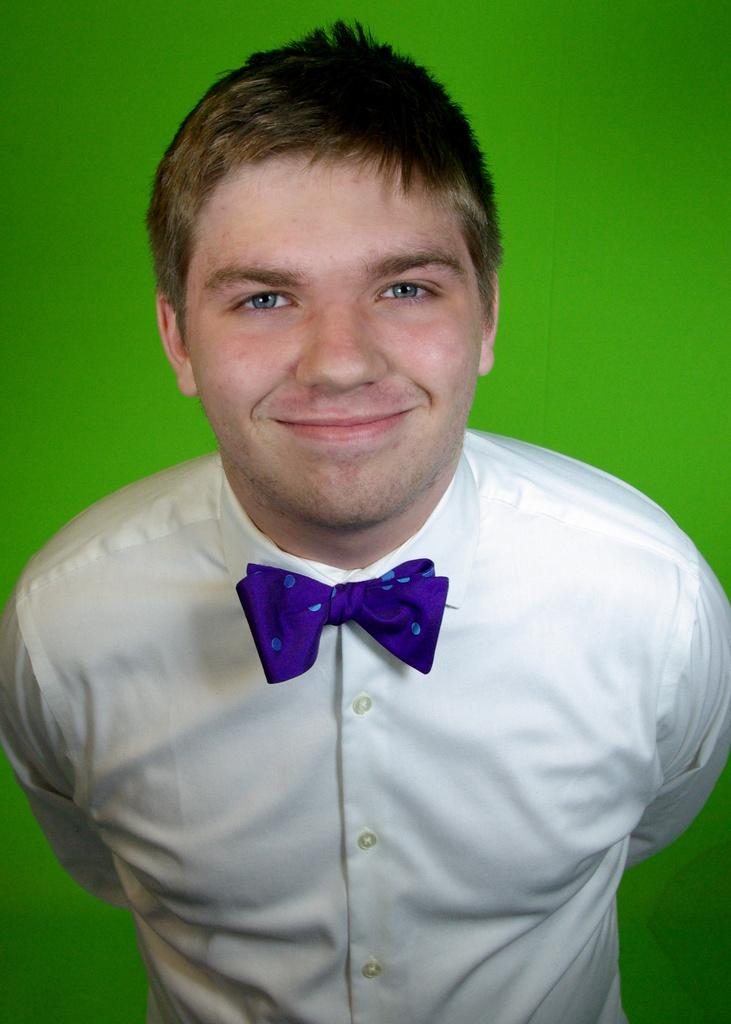Who is present in the image? There is a man in the image. What is the man wearing on his upper body? The man is wearing a white shirt and a blue tie. What is the man's facial expression in the image? The man has a smile on his face. What color can be seen in the background of the image? There is green color in the background of the image. What type of pot is visible in the image? There is no pot present in the image. What material is the duck made of in the image? There is no duck present in the image. 